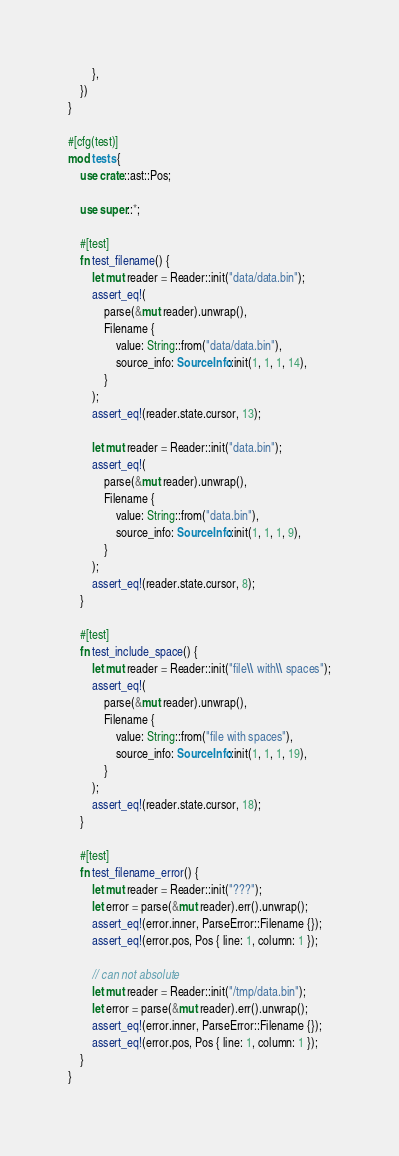<code> <loc_0><loc_0><loc_500><loc_500><_Rust_>        },
    })
}

#[cfg(test)]
mod tests {
    use crate::ast::Pos;

    use super::*;

    #[test]
    fn test_filename() {
        let mut reader = Reader::init("data/data.bin");
        assert_eq!(
            parse(&mut reader).unwrap(),
            Filename {
                value: String::from("data/data.bin"),
                source_info: SourceInfo::init(1, 1, 1, 14),
            }
        );
        assert_eq!(reader.state.cursor, 13);

        let mut reader = Reader::init("data.bin");
        assert_eq!(
            parse(&mut reader).unwrap(),
            Filename {
                value: String::from("data.bin"),
                source_info: SourceInfo::init(1, 1, 1, 9),
            }
        );
        assert_eq!(reader.state.cursor, 8);
    }

    #[test]
    fn test_include_space() {
        let mut reader = Reader::init("file\\ with\\ spaces");
        assert_eq!(
            parse(&mut reader).unwrap(),
            Filename {
                value: String::from("file with spaces"),
                source_info: SourceInfo::init(1, 1, 1, 19),
            }
        );
        assert_eq!(reader.state.cursor, 18);
    }

    #[test]
    fn test_filename_error() {
        let mut reader = Reader::init("???");
        let error = parse(&mut reader).err().unwrap();
        assert_eq!(error.inner, ParseError::Filename {});
        assert_eq!(error.pos, Pos { line: 1, column: 1 });

        // can not absolute
        let mut reader = Reader::init("/tmp/data.bin");
        let error = parse(&mut reader).err().unwrap();
        assert_eq!(error.inner, ParseError::Filename {});
        assert_eq!(error.pos, Pos { line: 1, column: 1 });
    }
}
</code> 